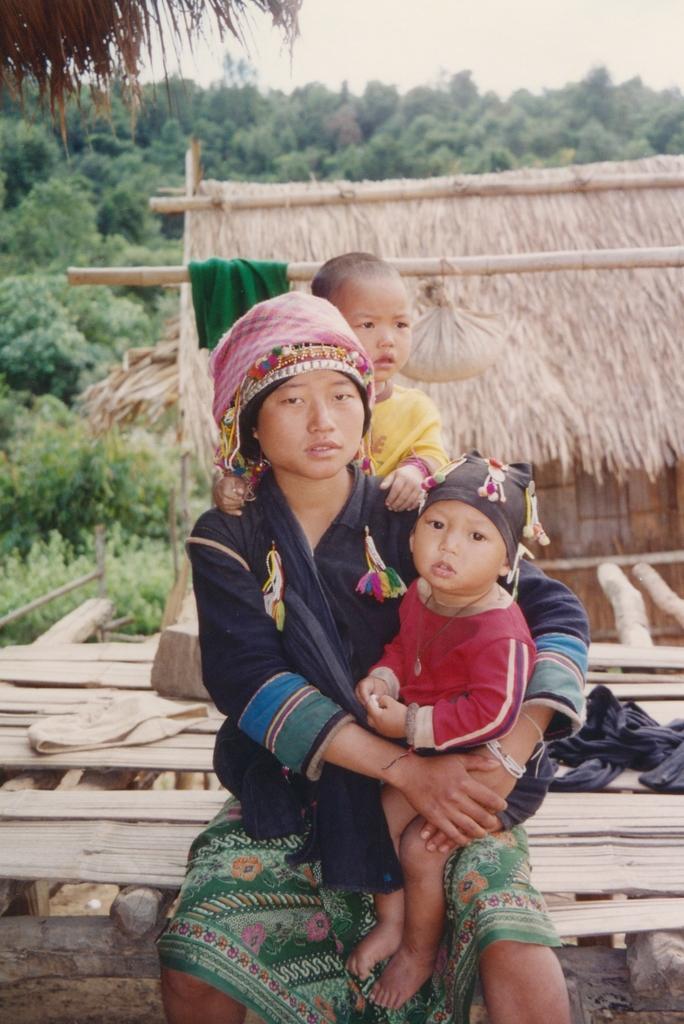How would you summarize this image in a sentence or two? In this image I can see three persons on a wooden bed. In the background I can see a hurt, trees and the sky. This image is taken may be during a day. 